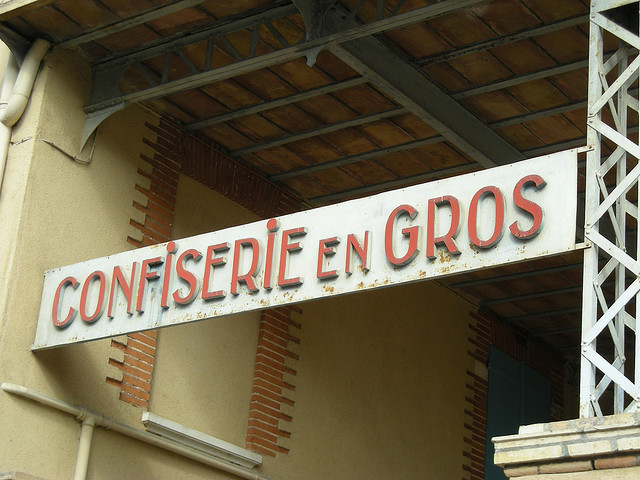Identify the text contained in this image. GROS EN CONFISERIE 